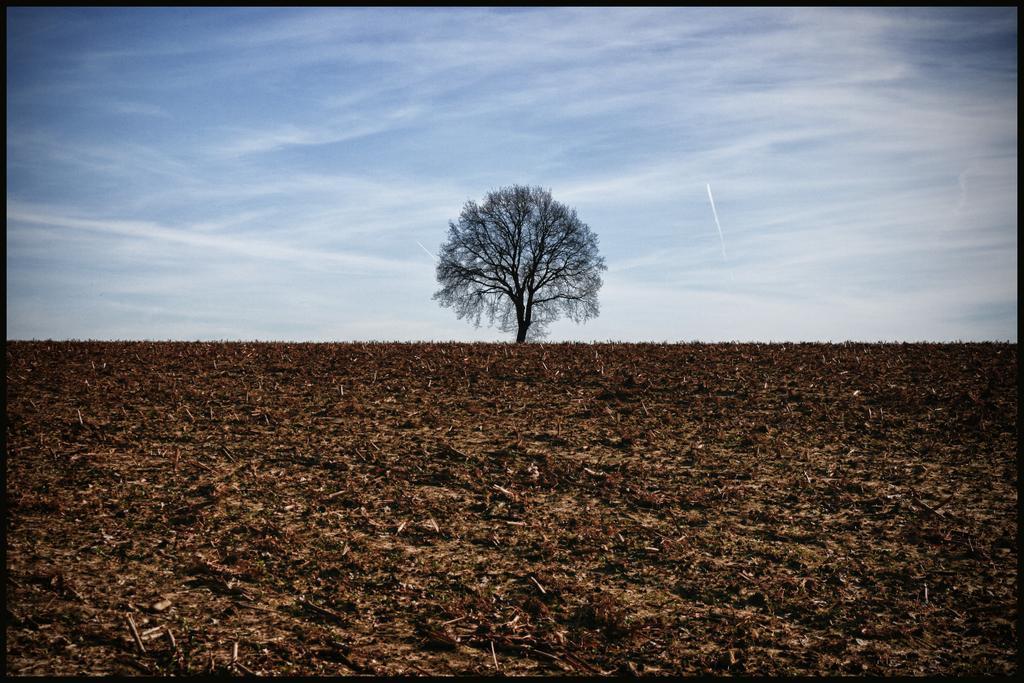Could you give a brief overview of what you see in this image? In this image there are dry leaves. In the background there is a tree and the sky is cloudy. 